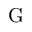<formula> <loc_0><loc_0><loc_500><loc_500>G</formula> 